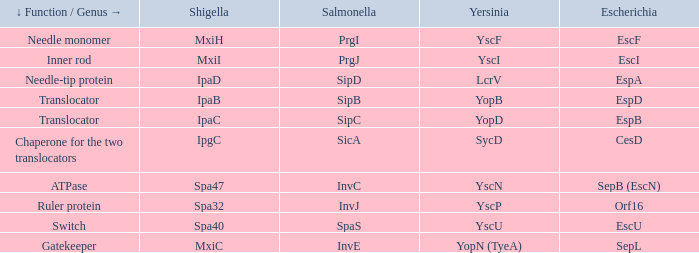Tell me the shigella and yscn Spa47. 